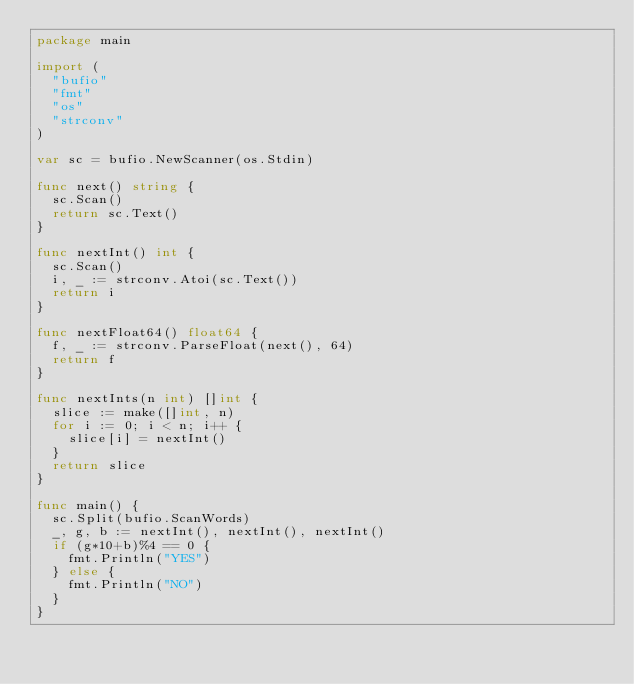<code> <loc_0><loc_0><loc_500><loc_500><_Go_>package main

import (
	"bufio"
	"fmt"
	"os"
	"strconv"
)

var sc = bufio.NewScanner(os.Stdin)

func next() string {
	sc.Scan()
	return sc.Text()
}

func nextInt() int {
	sc.Scan()
	i, _ := strconv.Atoi(sc.Text())
	return i
}

func nextFloat64() float64 {
	f, _ := strconv.ParseFloat(next(), 64)
	return f
}

func nextInts(n int) []int {
	slice := make([]int, n)
	for i := 0; i < n; i++ {
		slice[i] = nextInt()
	}
	return slice
}

func main() {
	sc.Split(bufio.ScanWords)
	_, g, b := nextInt(), nextInt(), nextInt()
	if (g*10+b)%4 == 0 {
		fmt.Println("YES")
	} else {
		fmt.Println("NO")
	}
}
</code> 